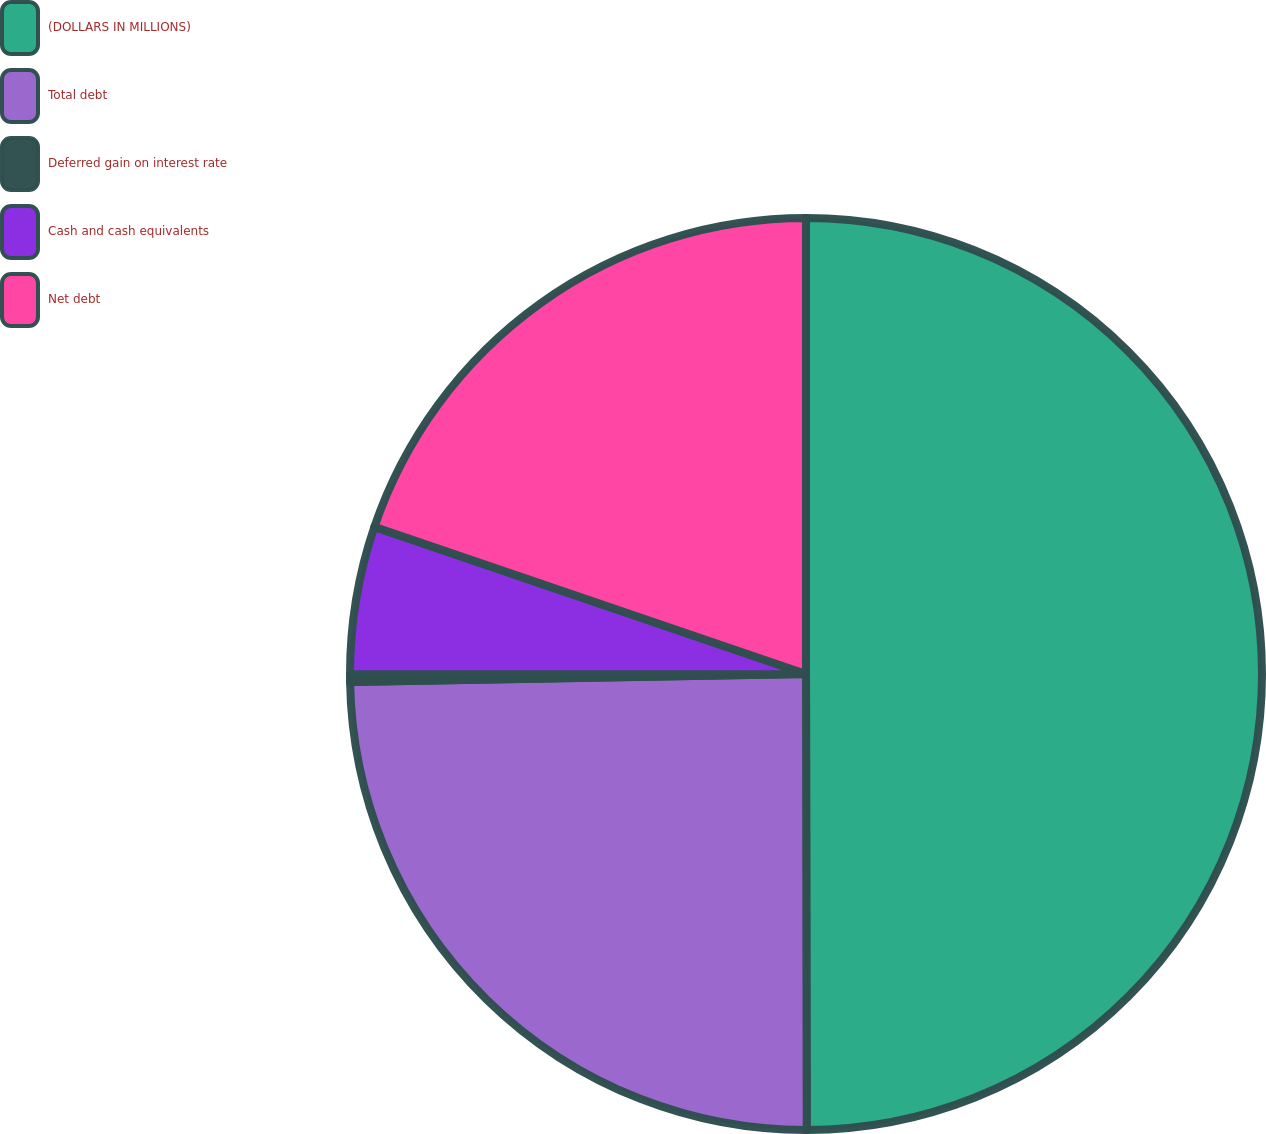Convert chart. <chart><loc_0><loc_0><loc_500><loc_500><pie_chart><fcel>(DOLLARS IN MILLIONS)<fcel>Total debt<fcel>Deferred gain on interest rate<fcel>Cash and cash equivalents<fcel>Net debt<nl><fcel>49.97%<fcel>24.74%<fcel>0.27%<fcel>5.24%<fcel>19.77%<nl></chart> 